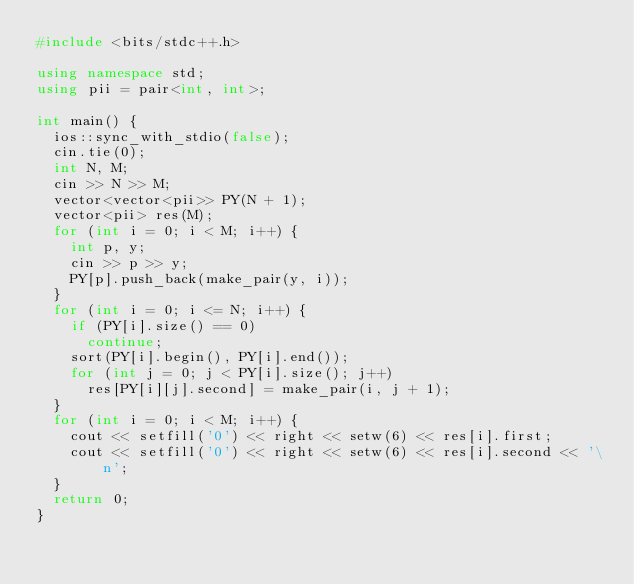<code> <loc_0><loc_0><loc_500><loc_500><_C++_>#include <bits/stdc++.h>

using namespace std;
using pii = pair<int, int>;

int main() {
  ios::sync_with_stdio(false);
  cin.tie(0);
  int N, M;
  cin >> N >> M;
  vector<vector<pii>> PY(N + 1);
  vector<pii> res(M);
  for (int i = 0; i < M; i++) {
    int p, y;
    cin >> p >> y;
    PY[p].push_back(make_pair(y, i));
  }
  for (int i = 0; i <= N; i++) {
    if (PY[i].size() == 0)
      continue;
    sort(PY[i].begin(), PY[i].end());
    for (int j = 0; j < PY[i].size(); j++)
      res[PY[i][j].second] = make_pair(i, j + 1);
  }
  for (int i = 0; i < M; i++) {
    cout << setfill('0') << right << setw(6) << res[i].first;
    cout << setfill('0') << right << setw(6) << res[i].second << '\n';
  }
  return 0;
}
</code> 